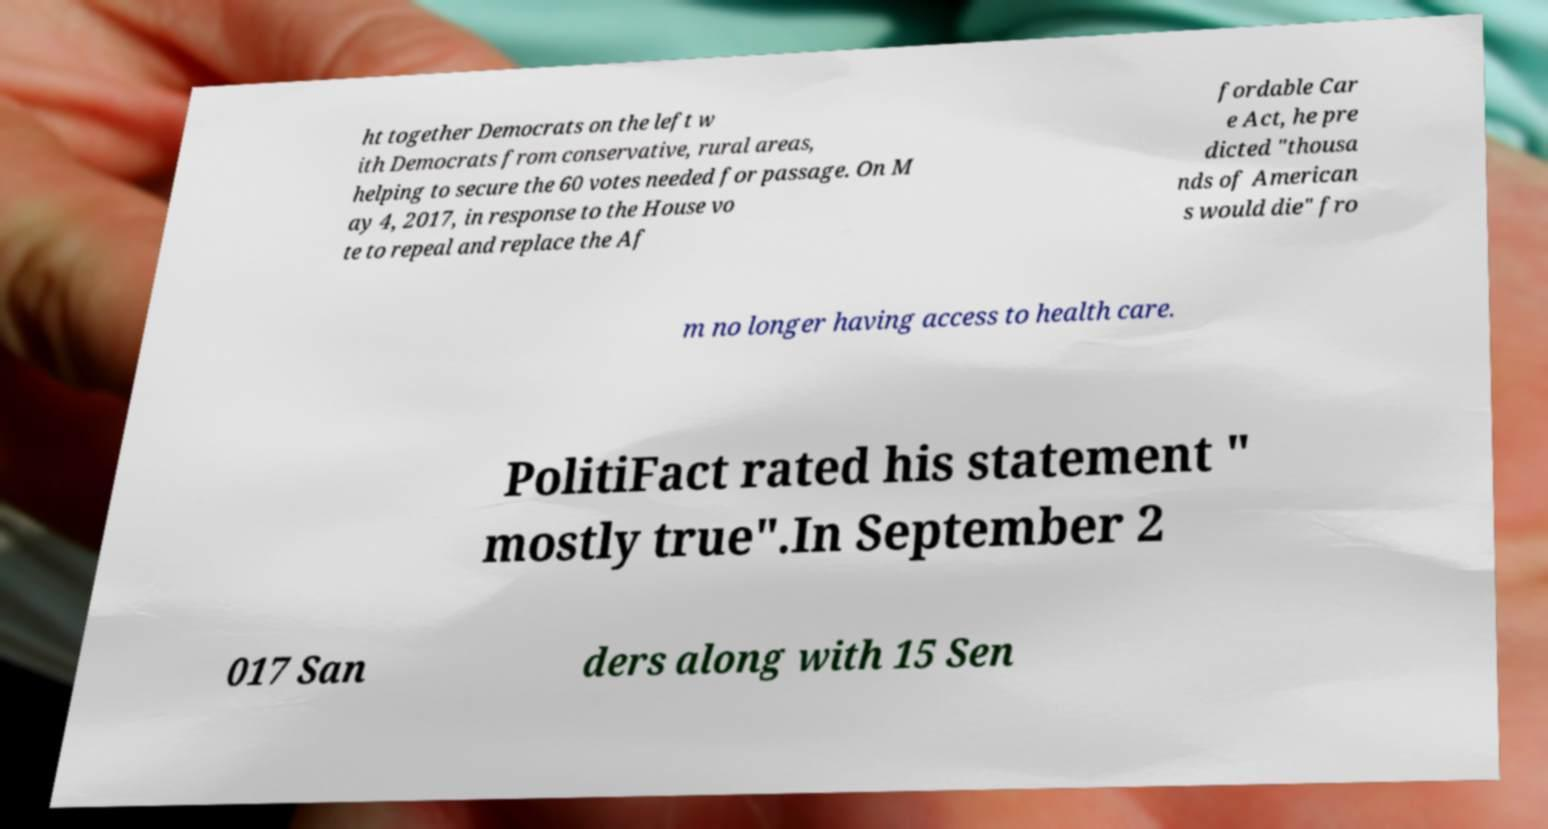Please read and relay the text visible in this image. What does it say? ht together Democrats on the left w ith Democrats from conservative, rural areas, helping to secure the 60 votes needed for passage. On M ay 4, 2017, in response to the House vo te to repeal and replace the Af fordable Car e Act, he pre dicted "thousa nds of American s would die" fro m no longer having access to health care. PolitiFact rated his statement " mostly true".In September 2 017 San ders along with 15 Sen 